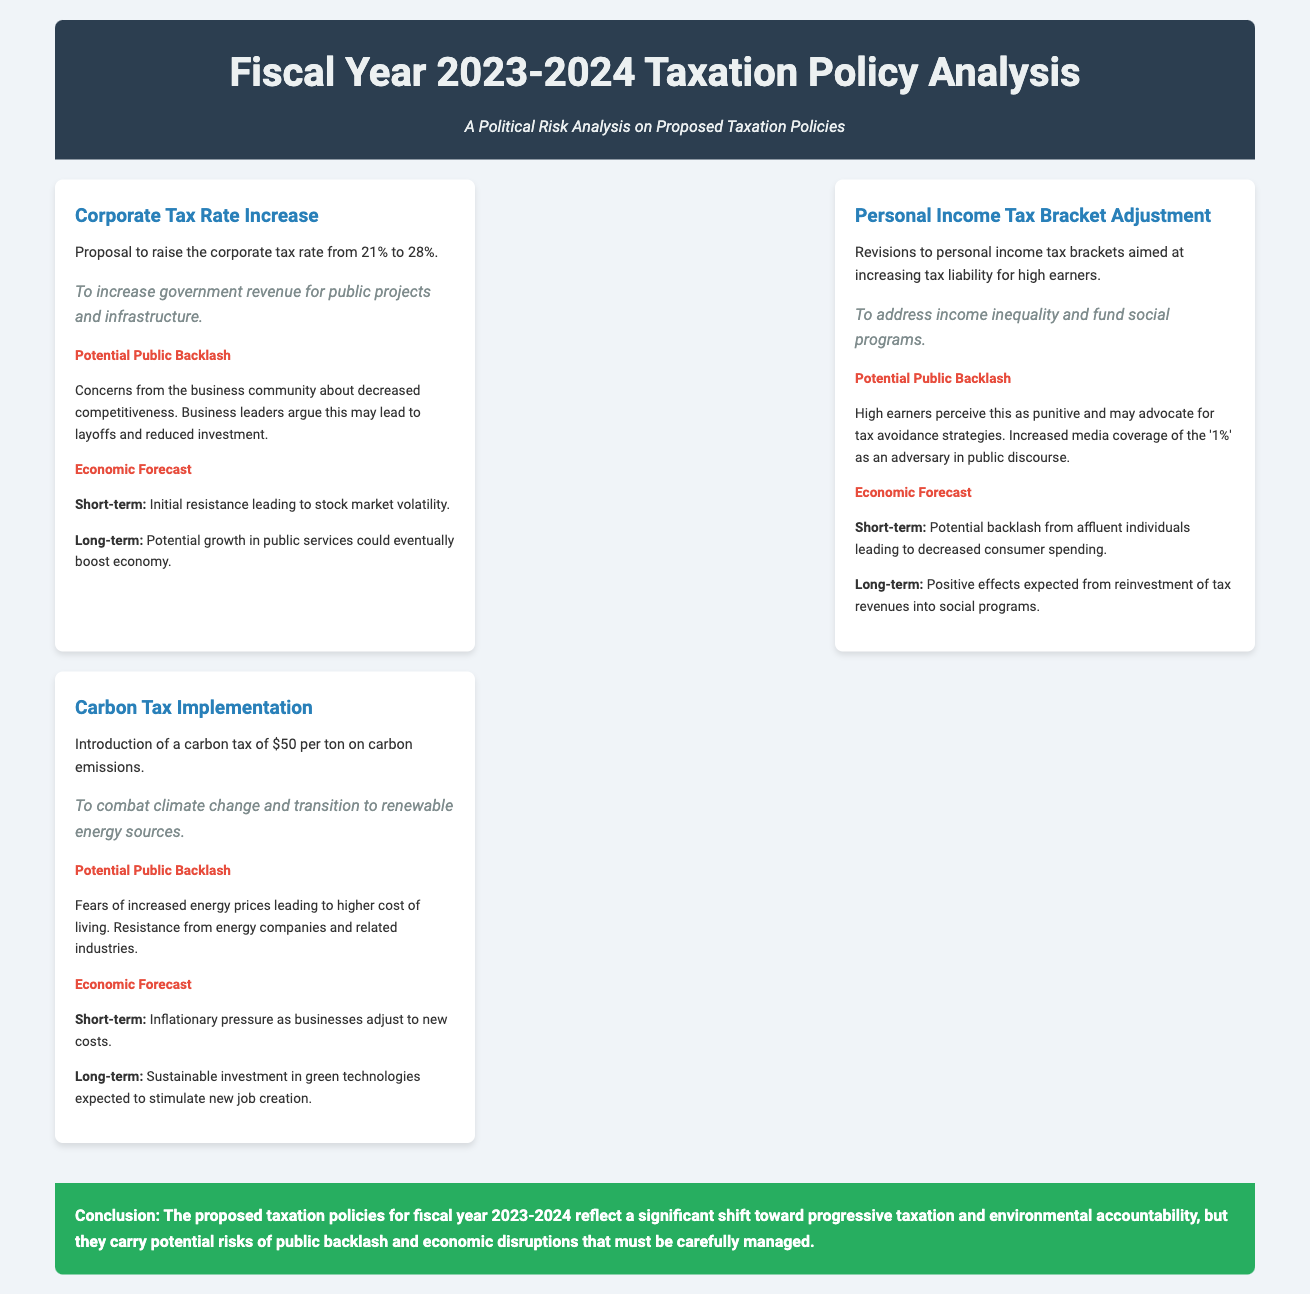what is the proposed corporate tax rate increase? The document states that the proposal is to raise the corporate tax rate from 21% to 28%.
Answer: 28% what is the rationale behind the personal income tax bracket adjustment? The rationale is to address income inequality and fund social programs.
Answer: Address income inequality and fund social programs what is the short-term economic forecast for the carbon tax implementation? The short-term economic forecast indicates inflationary pressure as businesses adjust to new costs.
Answer: Inflationary pressure what concerns does the business community have regarding the corporate tax rate increase? The concerns include decreased competitiveness, potential layoffs, and reduced investment.
Answer: Decreased competitiveness, layoffs, reduced investment how much is the proposed carbon tax per ton? The document specifies that the carbon tax is $50 per ton on carbon emissions.
Answer: $50 per ton 